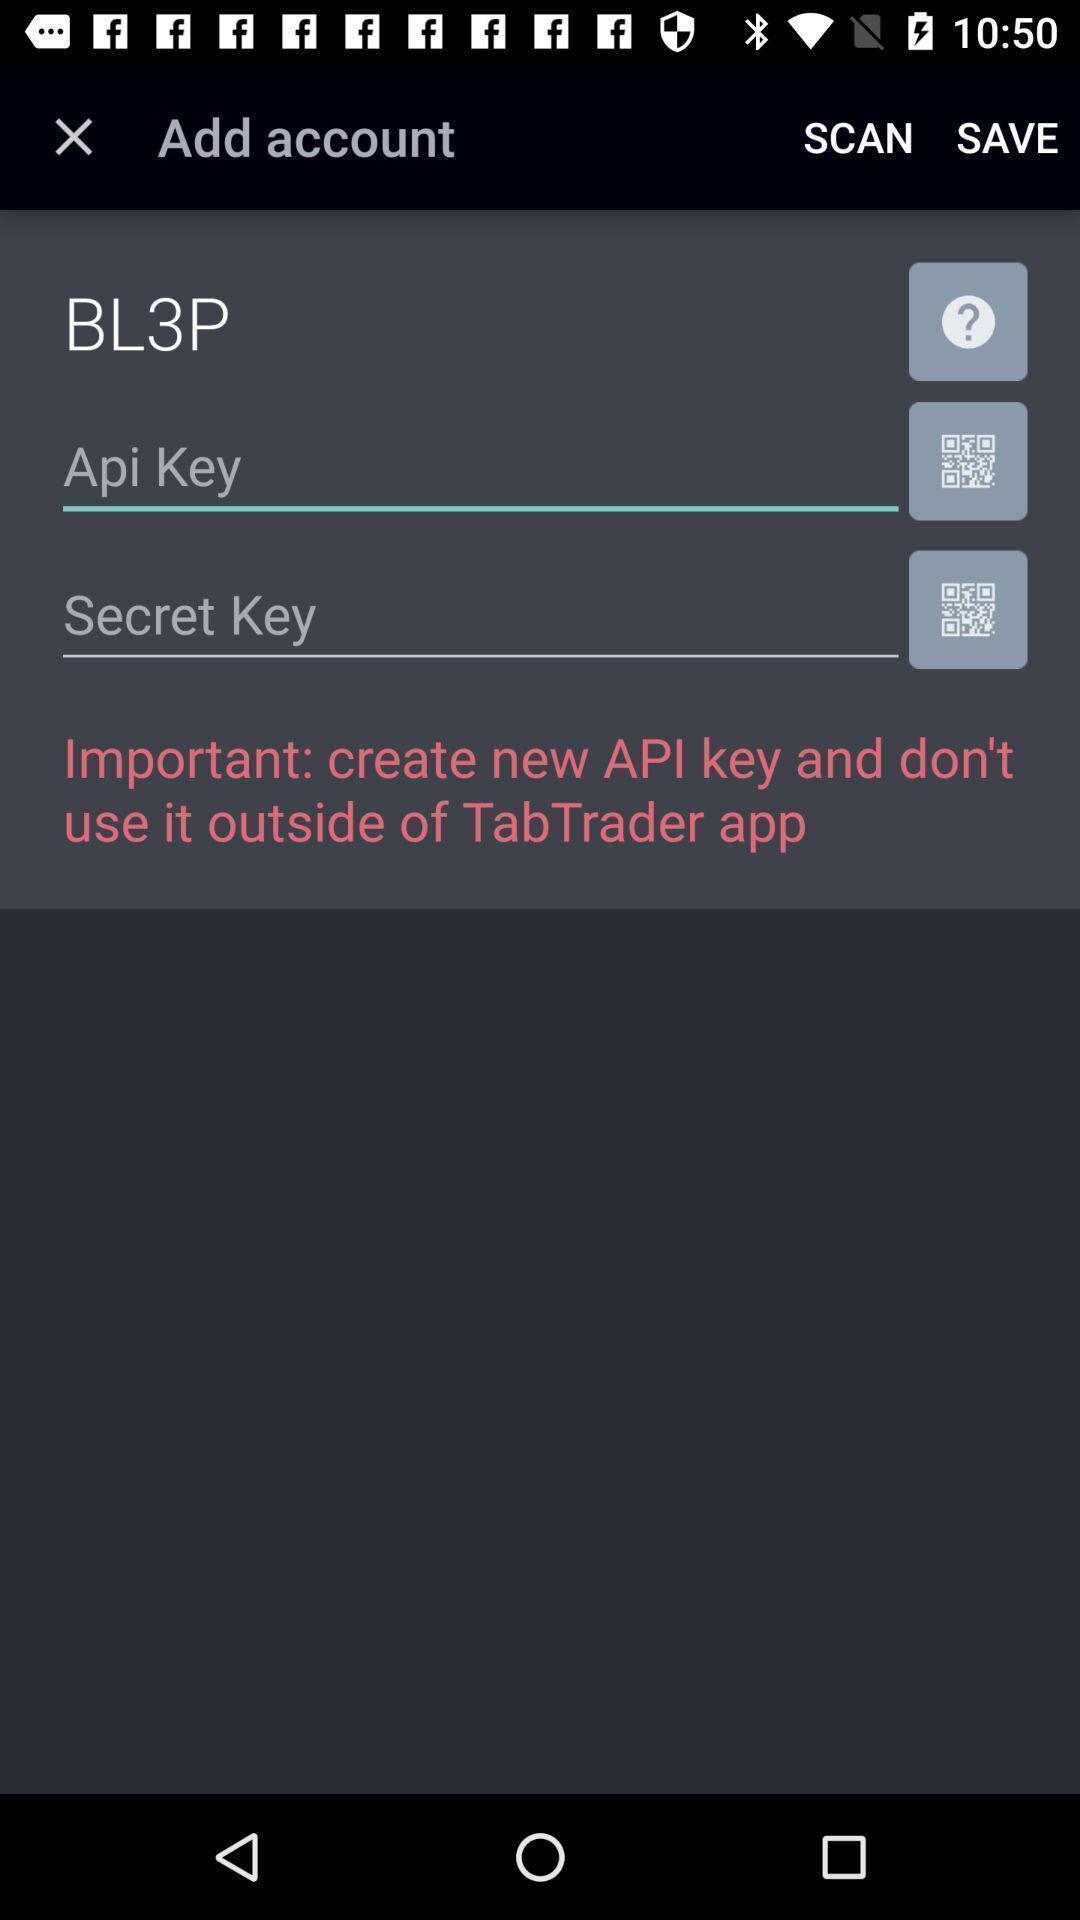Summarize the information in this screenshot. Screen shows multiple options. 